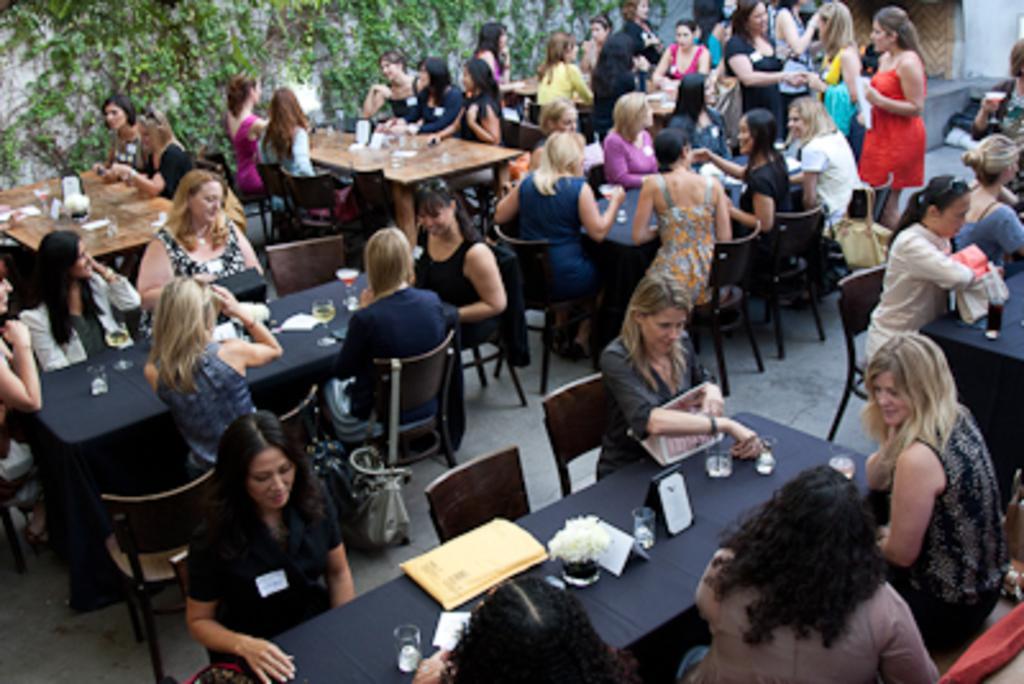Please provide a concise description of this image. in this image there are few people sitting on the chairs before the table. Few women are standing at the top right of the image. There are two glasses on the table which are served with drink. There is a flower vase on top of the table which are at the bottom of the image. The background, creepers are hanged to the wall 